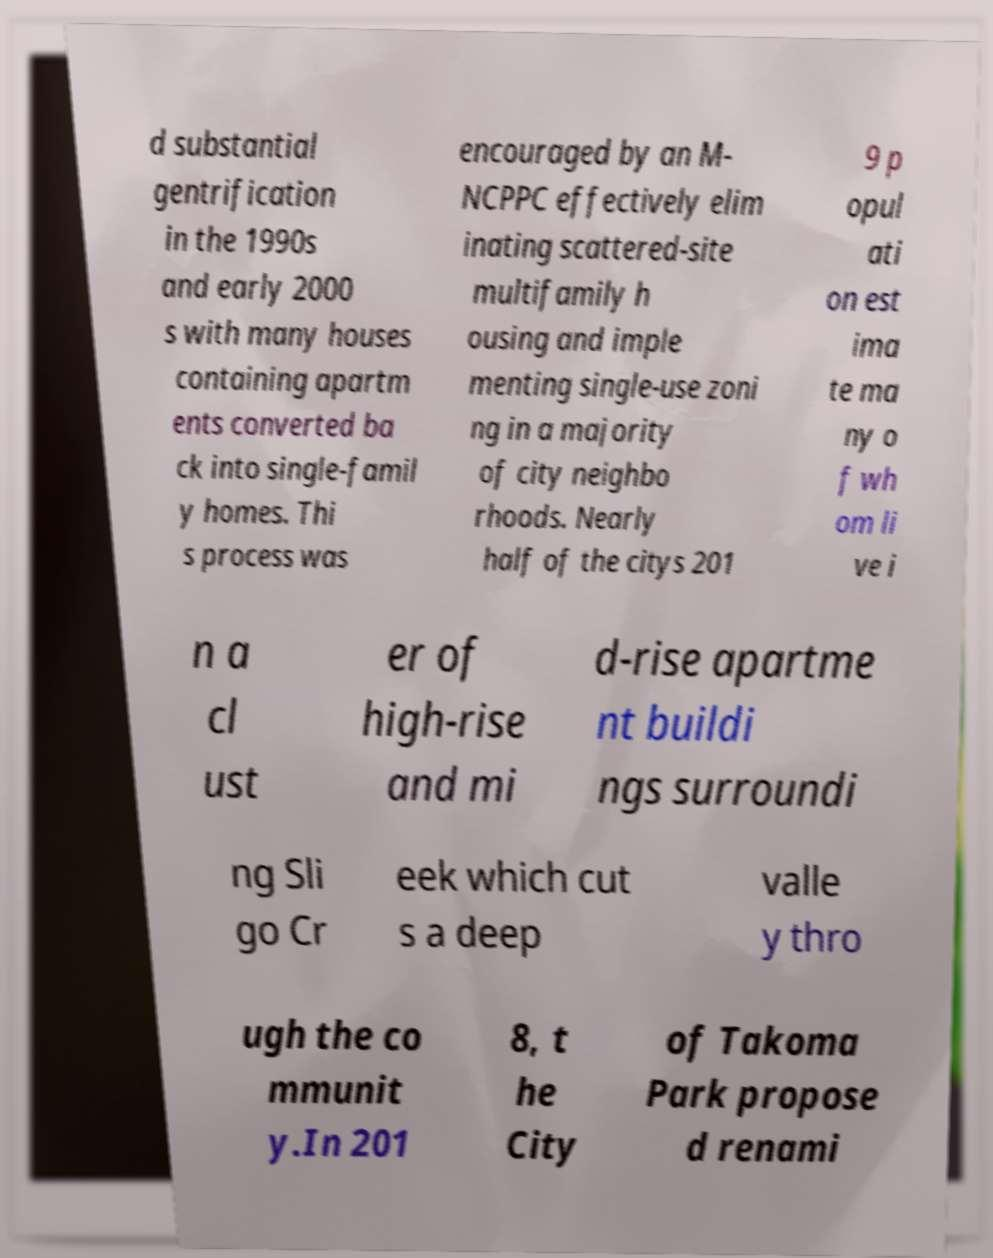There's text embedded in this image that I need extracted. Can you transcribe it verbatim? d substantial gentrification in the 1990s and early 2000 s with many houses containing apartm ents converted ba ck into single-famil y homes. Thi s process was encouraged by an M- NCPPC effectively elim inating scattered-site multifamily h ousing and imple menting single-use zoni ng in a majority of city neighbo rhoods. Nearly half of the citys 201 9 p opul ati on est ima te ma ny o f wh om li ve i n a cl ust er of high-rise and mi d-rise apartme nt buildi ngs surroundi ng Sli go Cr eek which cut s a deep valle y thro ugh the co mmunit y.In 201 8, t he City of Takoma Park propose d renami 